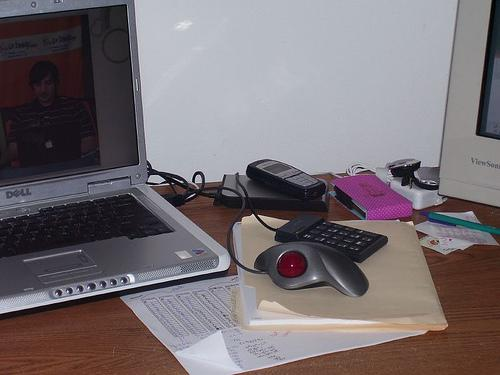Question: how many phones are on the desk?
Choices:
A. One phone.
B. Two.
C. Three.
D. Four.
Answer with the letter. Answer: A Question: what color are the walls?
Choices:
A. Black.
B. Brown.
C. White.
D. Beige.
Answer with the letter. Answer: C Question: what color is the mouse?
Choices:
A. Brown.
B. Light gray.
C. Grey.
D. Dark gray.
Answer with the letter. Answer: C 